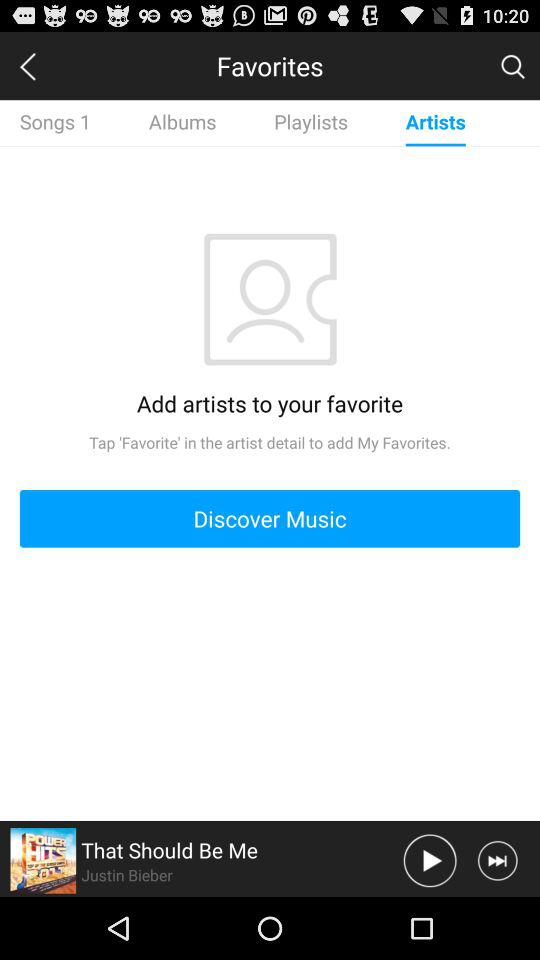Who is the singer of the song? The singer is Justin Bieber. 